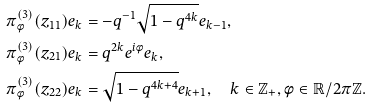<formula> <loc_0><loc_0><loc_500><loc_500>& \pi ^ { ( 3 ) } _ { \phi } ( z _ { 1 1 } ) e _ { k } = - q ^ { - 1 } \sqrt { 1 - q ^ { 4 k } } e _ { k - 1 } , \\ & \pi ^ { ( 3 ) } _ { \phi } ( z _ { 2 1 } ) e _ { k } = q ^ { 2 k } e ^ { i \phi } e _ { k } , \\ & \pi ^ { ( 3 ) } _ { \phi } ( z _ { 2 2 } ) e _ { k } = \sqrt { 1 - q ^ { 4 k + 4 } } e _ { k + 1 } , \quad k \in \mathbb { Z } _ { + } , \phi \in \mathbb { R } / 2 \pi \mathbb { Z } .</formula> 